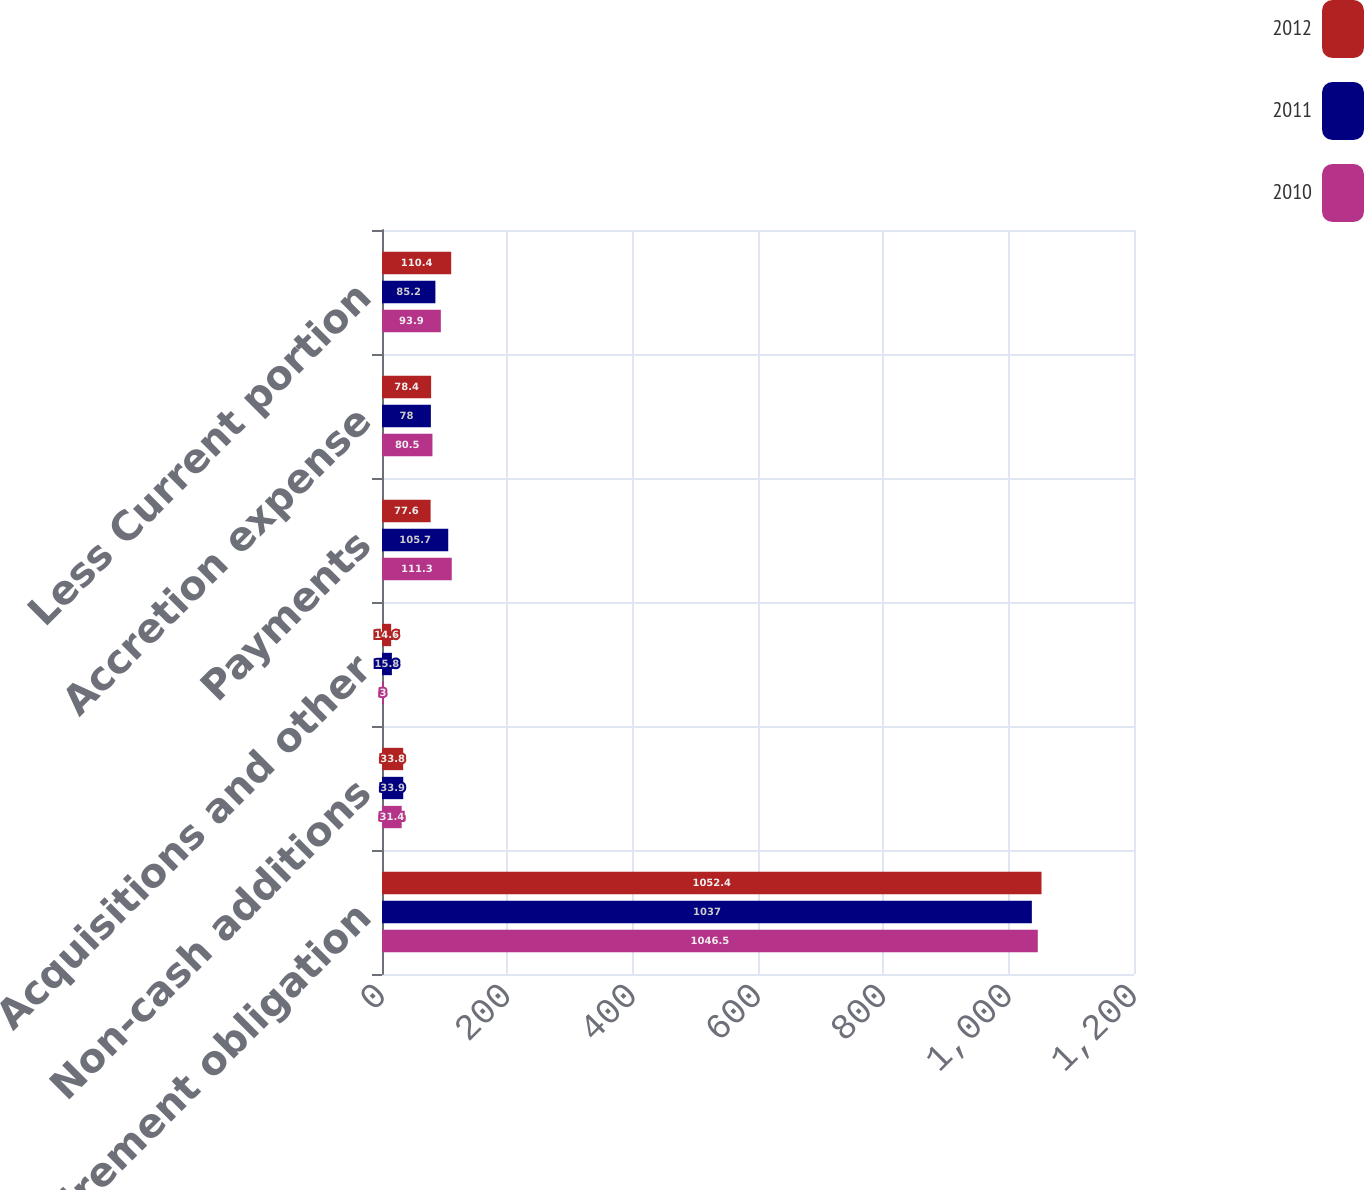Convert chart. <chart><loc_0><loc_0><loc_500><loc_500><stacked_bar_chart><ecel><fcel>Asset retirement obligation<fcel>Non-cash additions<fcel>Acquisitions and other<fcel>Payments<fcel>Accretion expense<fcel>Less Current portion<nl><fcel>2012<fcel>1052.4<fcel>33.8<fcel>14.6<fcel>77.6<fcel>78.4<fcel>110.4<nl><fcel>2011<fcel>1037<fcel>33.9<fcel>15.8<fcel>105.7<fcel>78<fcel>85.2<nl><fcel>2010<fcel>1046.5<fcel>31.4<fcel>3<fcel>111.3<fcel>80.5<fcel>93.9<nl></chart> 